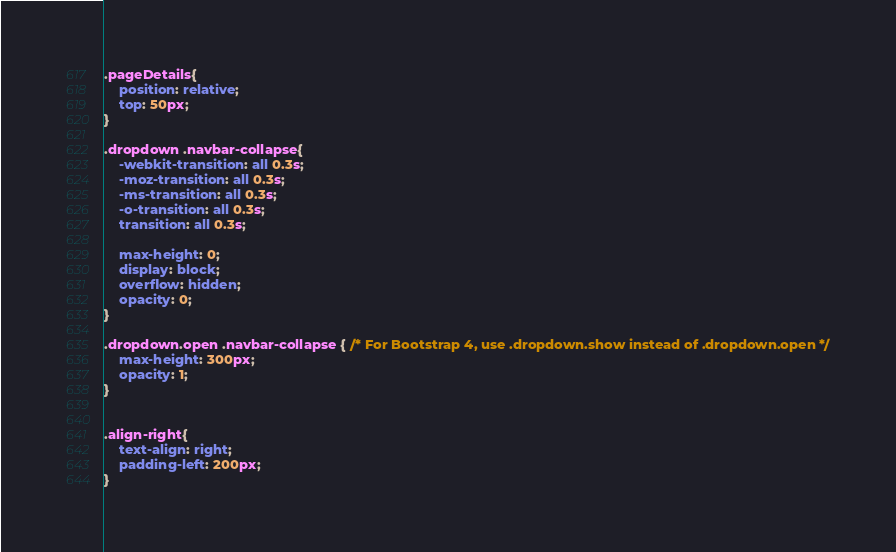Convert code to text. <code><loc_0><loc_0><loc_500><loc_500><_CSS_>.pageDetails{
    position: relative;
    top: 50px;
}

.dropdown .navbar-collapse{
    -webkit-transition: all 0.3s;
    -moz-transition: all 0.3s;
    -ms-transition: all 0.3s;
    -o-transition: all 0.3s;
    transition: all 0.3s;

    max-height: 0;
    display: block;
    overflow: hidden;
    opacity: 0;
}

.dropdown.open .navbar-collapse { /* For Bootstrap 4, use .dropdown.show instead of .dropdown.open */
    max-height: 300px;
    opacity: 1;
}


.align-right{
    text-align: right;
    padding-left: 200px;
}</code> 